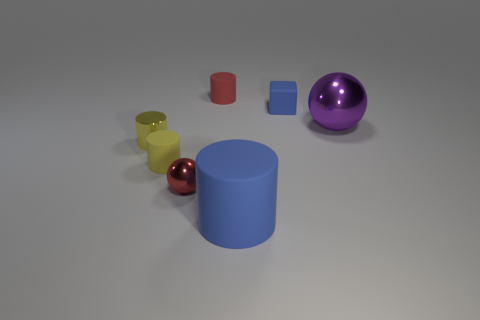There is a large thing to the right of the block; how many tiny red matte cylinders are in front of it?
Offer a terse response. 0. What size is the thing that is the same color as the small shiny ball?
Ensure brevity in your answer.  Small. What number of objects are either small blocks or shiny objects left of the red metallic object?
Your answer should be very brief. 2. Is there a big object that has the same material as the blue cube?
Make the answer very short. Yes. How many cylinders are both behind the blue cube and in front of the metallic cylinder?
Provide a short and direct response. 0. There is a small yellow cylinder right of the metal cylinder; what material is it?
Your response must be concise. Rubber. What is the size of the yellow cylinder that is made of the same material as the small red cylinder?
Ensure brevity in your answer.  Small. There is a large purple ball; are there any red metal objects in front of it?
Offer a very short reply. Yes. What is the size of the blue rubber object that is the same shape as the yellow metal object?
Give a very brief answer. Large. There is a small block; is it the same color as the sphere that is to the right of the big blue object?
Make the answer very short. No. 